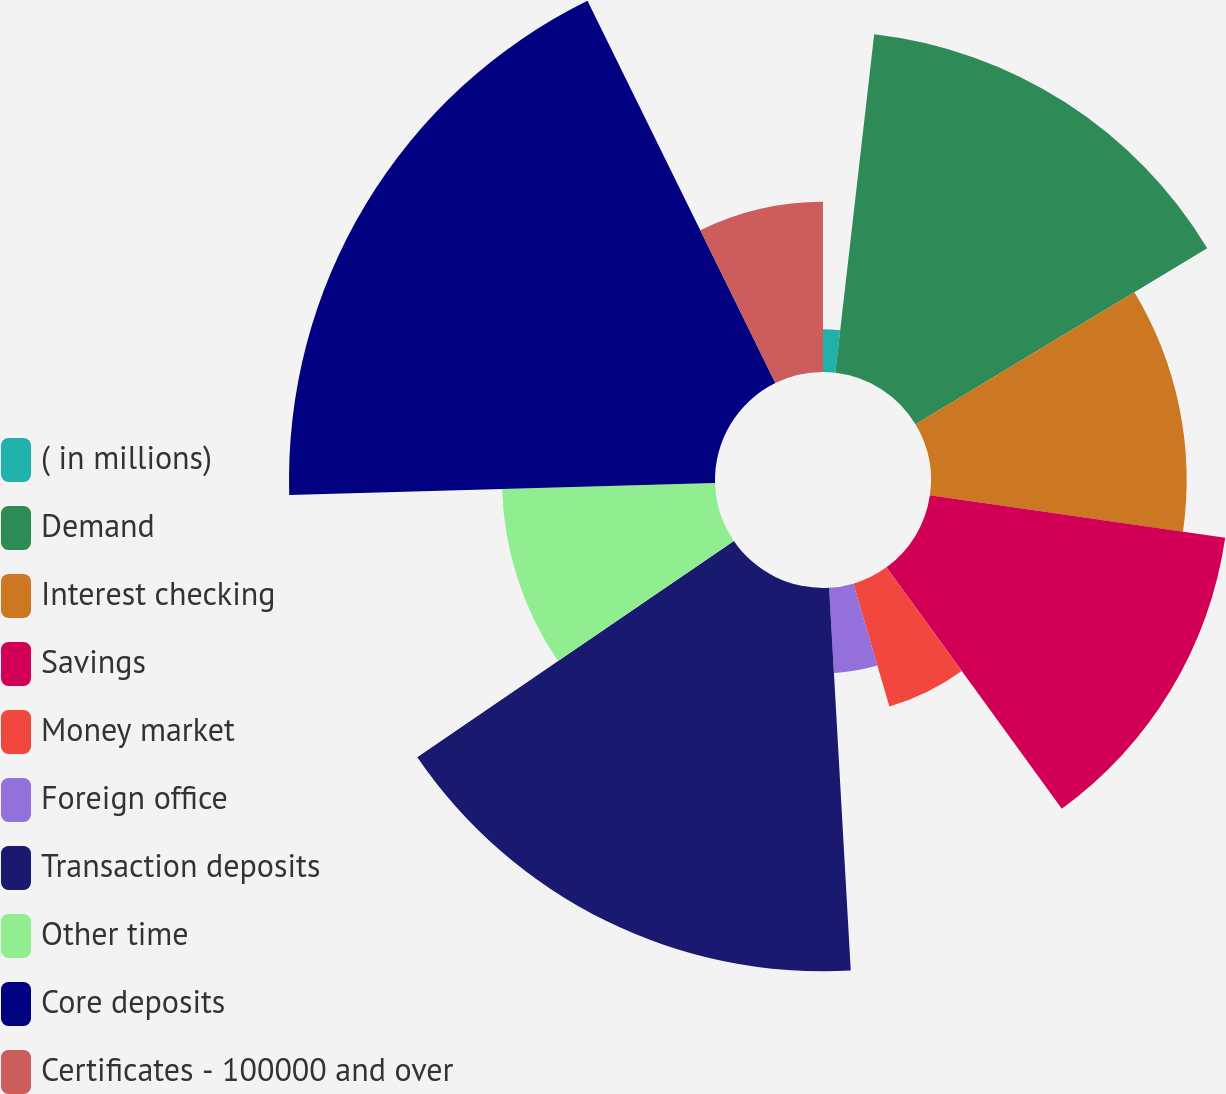Convert chart to OTSL. <chart><loc_0><loc_0><loc_500><loc_500><pie_chart><fcel>( in millions)<fcel>Demand<fcel>Interest checking<fcel>Savings<fcel>Money market<fcel>Foreign office<fcel>Transaction deposits<fcel>Other time<fcel>Core deposits<fcel>Certificates - 100000 and over<nl><fcel>1.82%<fcel>14.54%<fcel>10.91%<fcel>12.73%<fcel>5.46%<fcel>3.64%<fcel>16.36%<fcel>9.09%<fcel>18.18%<fcel>7.27%<nl></chart> 